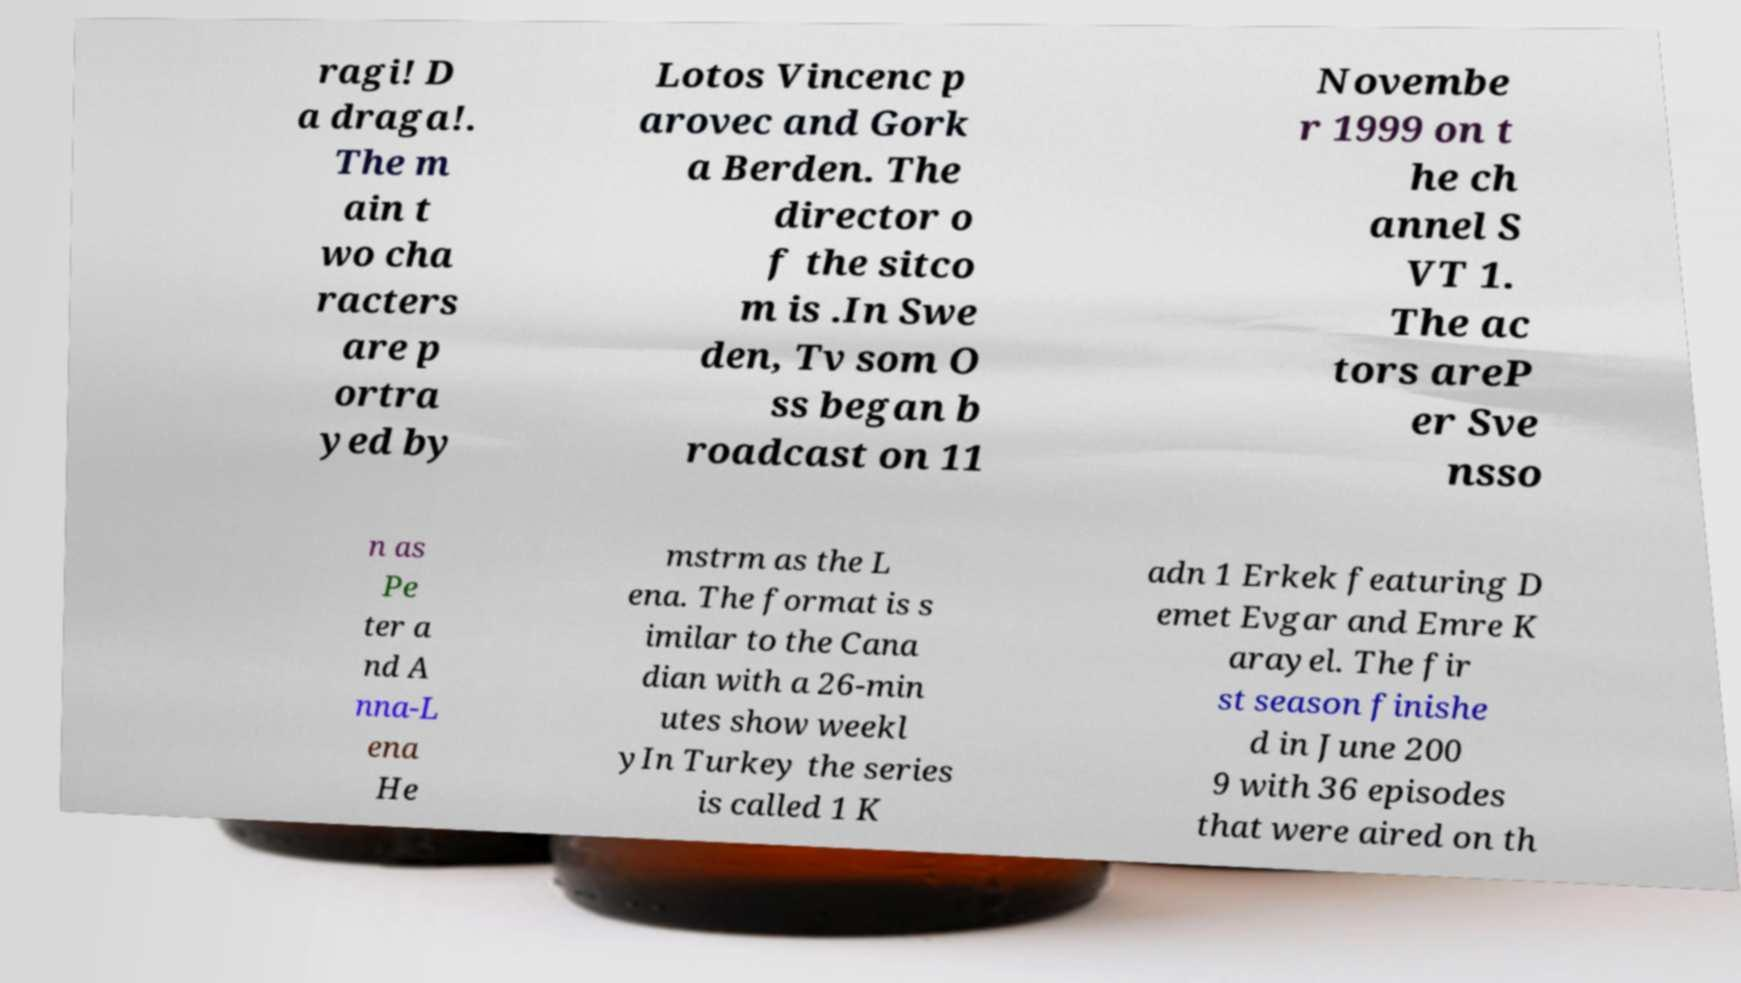Could you assist in decoding the text presented in this image and type it out clearly? ragi! D a draga!. The m ain t wo cha racters are p ortra yed by Lotos Vincenc p arovec and Gork a Berden. The director o f the sitco m is .In Swe den, Tv som O ss began b roadcast on 11 Novembe r 1999 on t he ch annel S VT 1. The ac tors areP er Sve nsso n as Pe ter a nd A nna-L ena He mstrm as the L ena. The format is s imilar to the Cana dian with a 26-min utes show weekl yIn Turkey the series is called 1 K adn 1 Erkek featuring D emet Evgar and Emre K arayel. The fir st season finishe d in June 200 9 with 36 episodes that were aired on th 